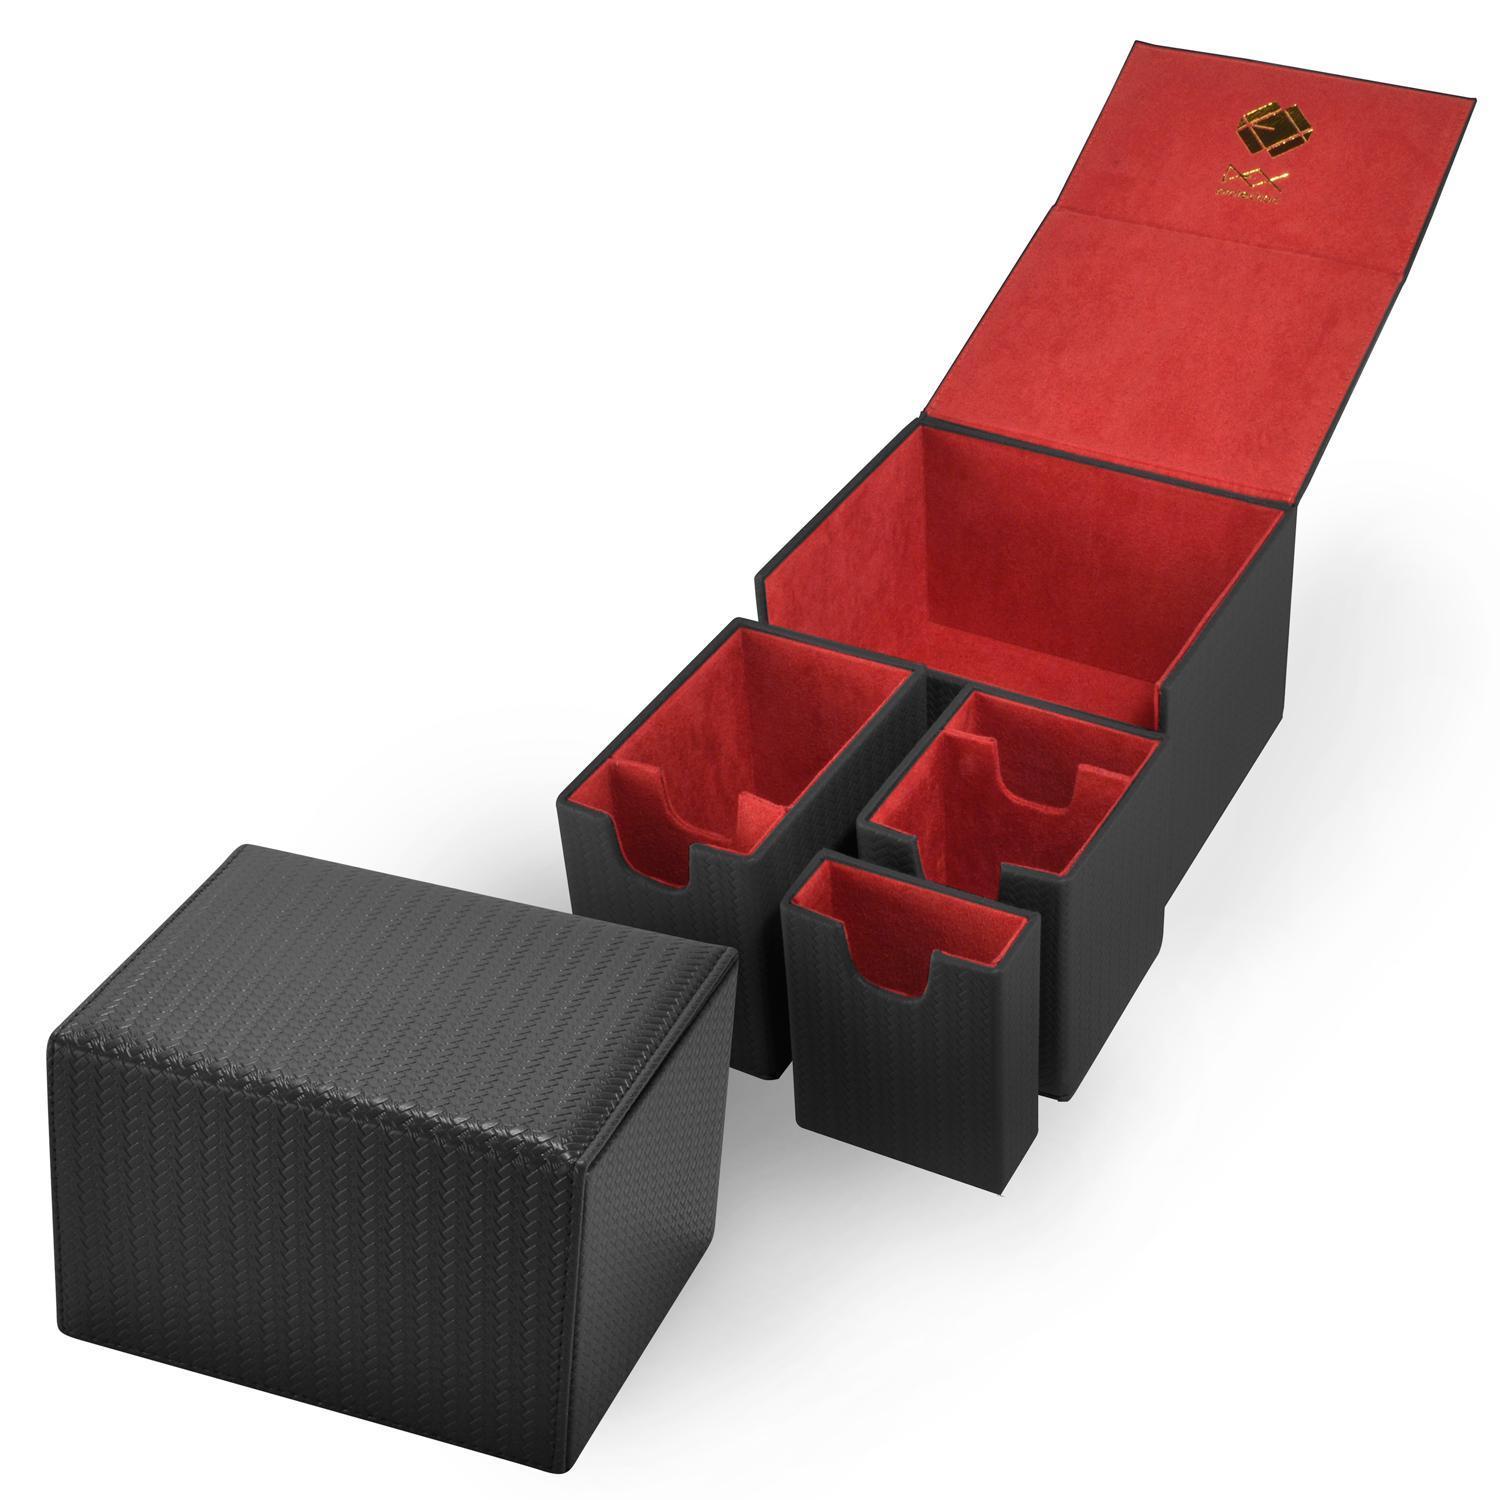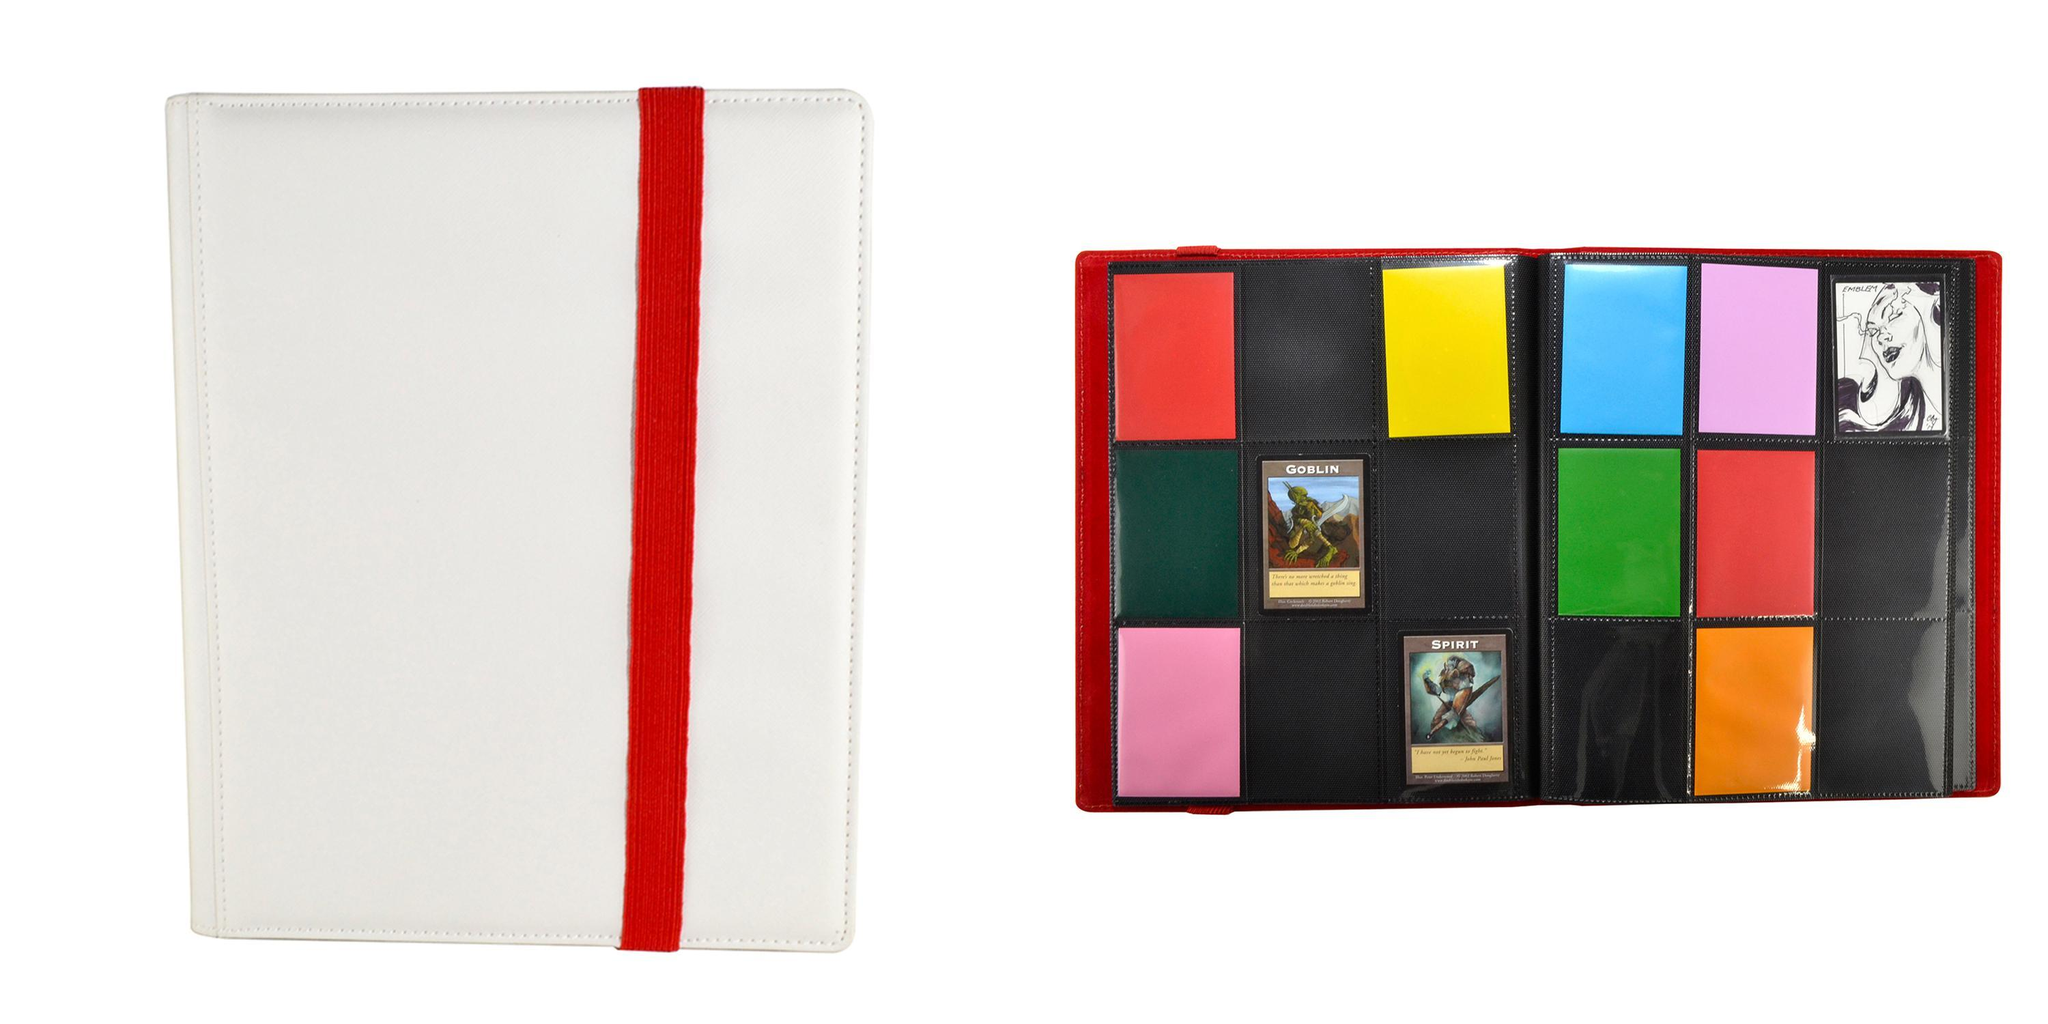The first image is the image on the left, the second image is the image on the right. For the images displayed, is the sentence "There is a single folder on the left image." factually correct? Answer yes or no. No. 